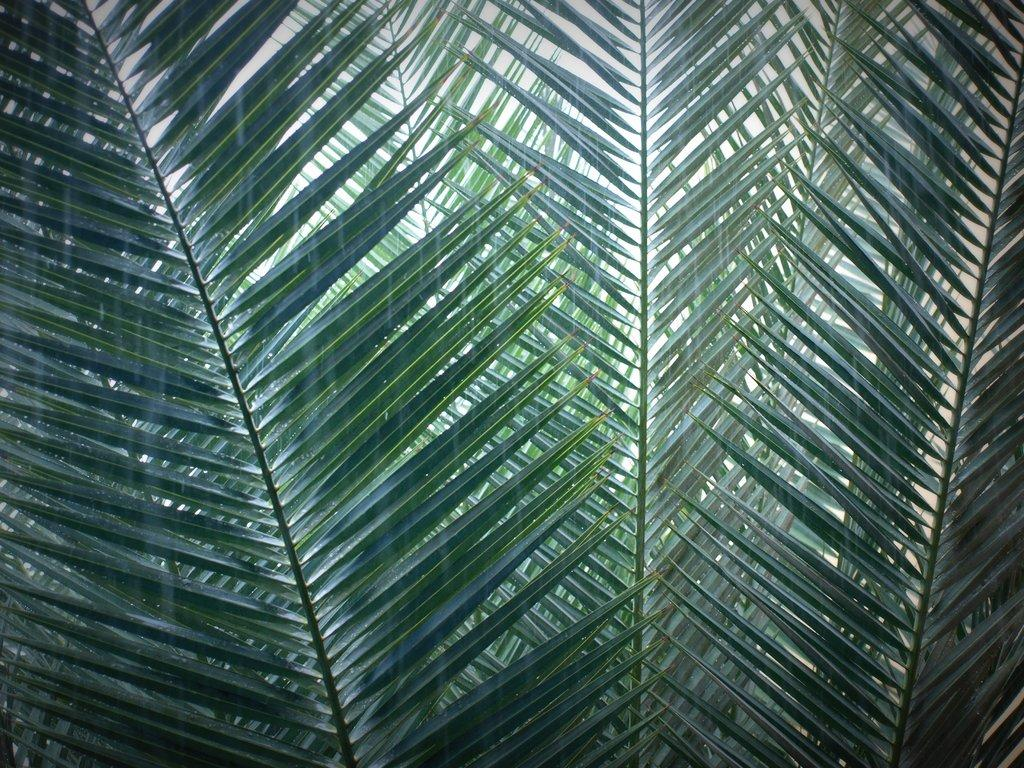What type of vegetation is present in the image? There are leaves of a tree in the image. What part of the natural environment is visible in the image? The sky is visible in the image. What is the fear of the leaves in the image? There is no indication of fear in the image, as leaves are inanimate objects and do not experience emotions. 